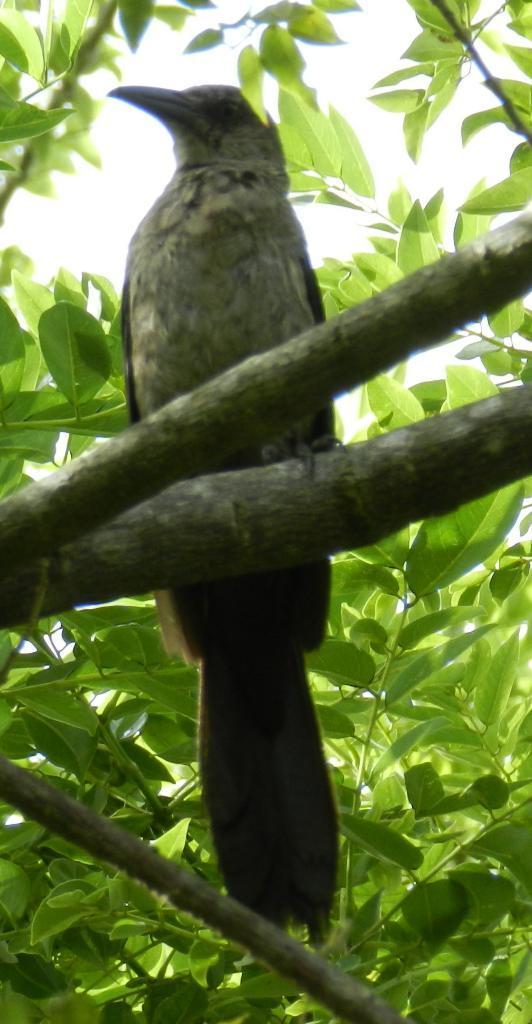Describe this image in one or two sentences. In this image we can see a bird on the tree. In the background there is a sky. 